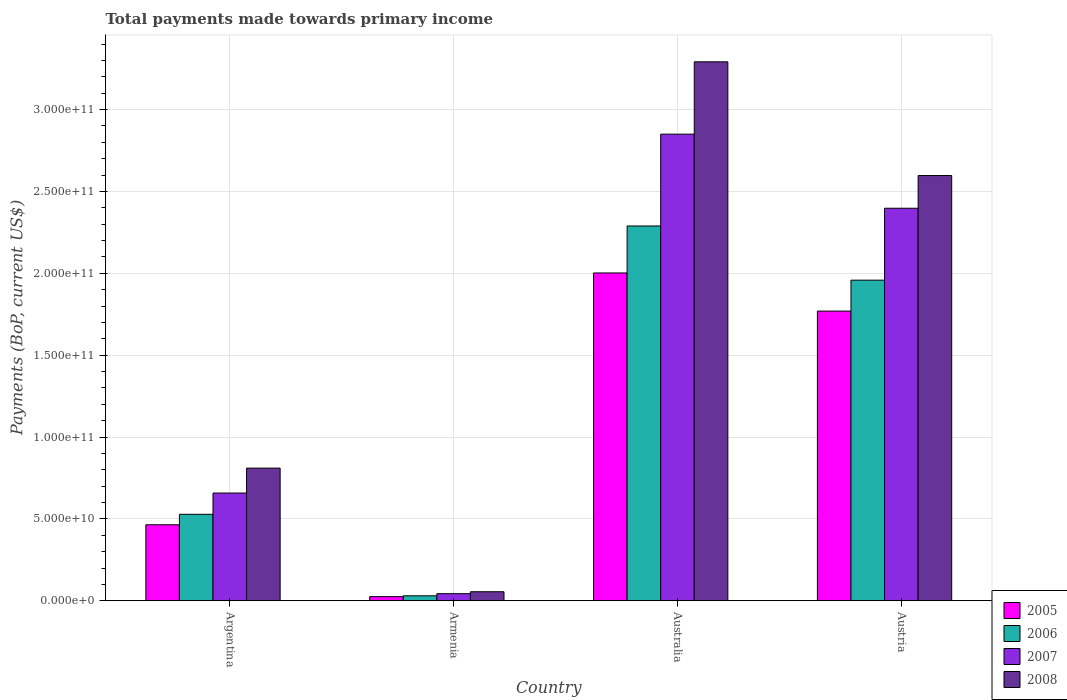How many groups of bars are there?
Provide a succinct answer. 4. Are the number of bars on each tick of the X-axis equal?
Your response must be concise. Yes. How many bars are there on the 3rd tick from the left?
Keep it short and to the point. 4. What is the label of the 2nd group of bars from the left?
Give a very brief answer. Armenia. In how many cases, is the number of bars for a given country not equal to the number of legend labels?
Your answer should be compact. 0. What is the total payments made towards primary income in 2005 in Argentina?
Give a very brief answer. 4.64e+1. Across all countries, what is the maximum total payments made towards primary income in 2006?
Provide a short and direct response. 2.29e+11. Across all countries, what is the minimum total payments made towards primary income in 2008?
Your answer should be very brief. 5.51e+09. In which country was the total payments made towards primary income in 2006 maximum?
Ensure brevity in your answer.  Australia. In which country was the total payments made towards primary income in 2005 minimum?
Give a very brief answer. Armenia. What is the total total payments made towards primary income in 2007 in the graph?
Your response must be concise. 5.95e+11. What is the difference between the total payments made towards primary income in 2006 in Argentina and that in Austria?
Offer a very short reply. -1.43e+11. What is the difference between the total payments made towards primary income in 2007 in Australia and the total payments made towards primary income in 2006 in Austria?
Offer a very short reply. 8.92e+1. What is the average total payments made towards primary income in 2008 per country?
Your answer should be compact. 1.69e+11. What is the difference between the total payments made towards primary income of/in 2006 and total payments made towards primary income of/in 2007 in Austria?
Offer a very short reply. -4.39e+1. In how many countries, is the total payments made towards primary income in 2005 greater than 20000000000 US$?
Provide a short and direct response. 3. What is the ratio of the total payments made towards primary income in 2006 in Armenia to that in Australia?
Make the answer very short. 0.01. Is the difference between the total payments made towards primary income in 2006 in Argentina and Austria greater than the difference between the total payments made towards primary income in 2007 in Argentina and Austria?
Keep it short and to the point. Yes. What is the difference between the highest and the second highest total payments made towards primary income in 2005?
Provide a short and direct response. -1.54e+11. What is the difference between the highest and the lowest total payments made towards primary income in 2007?
Ensure brevity in your answer.  2.81e+11. Is the sum of the total payments made towards primary income in 2006 in Argentina and Australia greater than the maximum total payments made towards primary income in 2008 across all countries?
Provide a short and direct response. No. Is it the case that in every country, the sum of the total payments made towards primary income in 2007 and total payments made towards primary income in 2006 is greater than the total payments made towards primary income in 2008?
Offer a terse response. Yes. How many countries are there in the graph?
Provide a short and direct response. 4. Are the values on the major ticks of Y-axis written in scientific E-notation?
Your answer should be very brief. Yes. Does the graph contain any zero values?
Offer a very short reply. No. Where does the legend appear in the graph?
Make the answer very short. Bottom right. What is the title of the graph?
Provide a succinct answer. Total payments made towards primary income. Does "1987" appear as one of the legend labels in the graph?
Provide a short and direct response. No. What is the label or title of the X-axis?
Provide a succinct answer. Country. What is the label or title of the Y-axis?
Your response must be concise. Payments (BoP, current US$). What is the Payments (BoP, current US$) in 2005 in Argentina?
Your answer should be compact. 4.64e+1. What is the Payments (BoP, current US$) in 2006 in Argentina?
Offer a terse response. 5.28e+1. What is the Payments (BoP, current US$) in 2007 in Argentina?
Make the answer very short. 6.58e+1. What is the Payments (BoP, current US$) of 2008 in Argentina?
Offer a very short reply. 8.10e+1. What is the Payments (BoP, current US$) of 2005 in Armenia?
Your answer should be compact. 2.52e+09. What is the Payments (BoP, current US$) in 2006 in Armenia?
Ensure brevity in your answer.  3.04e+09. What is the Payments (BoP, current US$) in 2007 in Armenia?
Keep it short and to the point. 4.33e+09. What is the Payments (BoP, current US$) of 2008 in Armenia?
Make the answer very short. 5.51e+09. What is the Payments (BoP, current US$) of 2005 in Australia?
Make the answer very short. 2.00e+11. What is the Payments (BoP, current US$) in 2006 in Australia?
Offer a terse response. 2.29e+11. What is the Payments (BoP, current US$) in 2007 in Australia?
Your response must be concise. 2.85e+11. What is the Payments (BoP, current US$) in 2008 in Australia?
Provide a short and direct response. 3.29e+11. What is the Payments (BoP, current US$) of 2005 in Austria?
Your response must be concise. 1.77e+11. What is the Payments (BoP, current US$) in 2006 in Austria?
Offer a very short reply. 1.96e+11. What is the Payments (BoP, current US$) of 2007 in Austria?
Provide a short and direct response. 2.40e+11. What is the Payments (BoP, current US$) of 2008 in Austria?
Your answer should be compact. 2.60e+11. Across all countries, what is the maximum Payments (BoP, current US$) of 2005?
Ensure brevity in your answer.  2.00e+11. Across all countries, what is the maximum Payments (BoP, current US$) in 2006?
Your answer should be very brief. 2.29e+11. Across all countries, what is the maximum Payments (BoP, current US$) of 2007?
Provide a succinct answer. 2.85e+11. Across all countries, what is the maximum Payments (BoP, current US$) of 2008?
Your response must be concise. 3.29e+11. Across all countries, what is the minimum Payments (BoP, current US$) of 2005?
Keep it short and to the point. 2.52e+09. Across all countries, what is the minimum Payments (BoP, current US$) in 2006?
Offer a very short reply. 3.04e+09. Across all countries, what is the minimum Payments (BoP, current US$) in 2007?
Ensure brevity in your answer.  4.33e+09. Across all countries, what is the minimum Payments (BoP, current US$) in 2008?
Your response must be concise. 5.51e+09. What is the total Payments (BoP, current US$) of 2005 in the graph?
Your answer should be compact. 4.26e+11. What is the total Payments (BoP, current US$) of 2006 in the graph?
Make the answer very short. 4.81e+11. What is the total Payments (BoP, current US$) of 2007 in the graph?
Offer a terse response. 5.95e+11. What is the total Payments (BoP, current US$) of 2008 in the graph?
Make the answer very short. 6.75e+11. What is the difference between the Payments (BoP, current US$) in 2005 in Argentina and that in Armenia?
Ensure brevity in your answer.  4.39e+1. What is the difference between the Payments (BoP, current US$) in 2006 in Argentina and that in Armenia?
Offer a very short reply. 4.98e+1. What is the difference between the Payments (BoP, current US$) of 2007 in Argentina and that in Armenia?
Offer a very short reply. 6.15e+1. What is the difference between the Payments (BoP, current US$) of 2008 in Argentina and that in Armenia?
Provide a succinct answer. 7.55e+1. What is the difference between the Payments (BoP, current US$) in 2005 in Argentina and that in Australia?
Your answer should be compact. -1.54e+11. What is the difference between the Payments (BoP, current US$) in 2006 in Argentina and that in Australia?
Your response must be concise. -1.76e+11. What is the difference between the Payments (BoP, current US$) of 2007 in Argentina and that in Australia?
Provide a short and direct response. -2.19e+11. What is the difference between the Payments (BoP, current US$) in 2008 in Argentina and that in Australia?
Give a very brief answer. -2.48e+11. What is the difference between the Payments (BoP, current US$) of 2005 in Argentina and that in Austria?
Ensure brevity in your answer.  -1.30e+11. What is the difference between the Payments (BoP, current US$) of 2006 in Argentina and that in Austria?
Provide a succinct answer. -1.43e+11. What is the difference between the Payments (BoP, current US$) of 2007 in Argentina and that in Austria?
Provide a short and direct response. -1.74e+11. What is the difference between the Payments (BoP, current US$) of 2008 in Argentina and that in Austria?
Provide a succinct answer. -1.79e+11. What is the difference between the Payments (BoP, current US$) in 2005 in Armenia and that in Australia?
Give a very brief answer. -1.98e+11. What is the difference between the Payments (BoP, current US$) of 2006 in Armenia and that in Australia?
Offer a terse response. -2.26e+11. What is the difference between the Payments (BoP, current US$) in 2007 in Armenia and that in Australia?
Provide a succinct answer. -2.81e+11. What is the difference between the Payments (BoP, current US$) in 2008 in Armenia and that in Australia?
Offer a very short reply. -3.24e+11. What is the difference between the Payments (BoP, current US$) of 2005 in Armenia and that in Austria?
Make the answer very short. -1.74e+11. What is the difference between the Payments (BoP, current US$) of 2006 in Armenia and that in Austria?
Offer a very short reply. -1.93e+11. What is the difference between the Payments (BoP, current US$) of 2007 in Armenia and that in Austria?
Make the answer very short. -2.35e+11. What is the difference between the Payments (BoP, current US$) in 2008 in Armenia and that in Austria?
Offer a very short reply. -2.54e+11. What is the difference between the Payments (BoP, current US$) of 2005 in Australia and that in Austria?
Offer a very short reply. 2.33e+1. What is the difference between the Payments (BoP, current US$) of 2006 in Australia and that in Austria?
Your answer should be compact. 3.31e+1. What is the difference between the Payments (BoP, current US$) of 2007 in Australia and that in Austria?
Your answer should be very brief. 4.52e+1. What is the difference between the Payments (BoP, current US$) in 2008 in Australia and that in Austria?
Make the answer very short. 6.94e+1. What is the difference between the Payments (BoP, current US$) of 2005 in Argentina and the Payments (BoP, current US$) of 2006 in Armenia?
Your answer should be compact. 4.34e+1. What is the difference between the Payments (BoP, current US$) in 2005 in Argentina and the Payments (BoP, current US$) in 2007 in Armenia?
Keep it short and to the point. 4.21e+1. What is the difference between the Payments (BoP, current US$) in 2005 in Argentina and the Payments (BoP, current US$) in 2008 in Armenia?
Make the answer very short. 4.09e+1. What is the difference between the Payments (BoP, current US$) of 2006 in Argentina and the Payments (BoP, current US$) of 2007 in Armenia?
Your answer should be compact. 4.85e+1. What is the difference between the Payments (BoP, current US$) of 2006 in Argentina and the Payments (BoP, current US$) of 2008 in Armenia?
Make the answer very short. 4.73e+1. What is the difference between the Payments (BoP, current US$) of 2007 in Argentina and the Payments (BoP, current US$) of 2008 in Armenia?
Offer a very short reply. 6.03e+1. What is the difference between the Payments (BoP, current US$) of 2005 in Argentina and the Payments (BoP, current US$) of 2006 in Australia?
Make the answer very short. -1.82e+11. What is the difference between the Payments (BoP, current US$) in 2005 in Argentina and the Payments (BoP, current US$) in 2007 in Australia?
Your answer should be compact. -2.39e+11. What is the difference between the Payments (BoP, current US$) in 2005 in Argentina and the Payments (BoP, current US$) in 2008 in Australia?
Make the answer very short. -2.83e+11. What is the difference between the Payments (BoP, current US$) in 2006 in Argentina and the Payments (BoP, current US$) in 2007 in Australia?
Your answer should be very brief. -2.32e+11. What is the difference between the Payments (BoP, current US$) in 2006 in Argentina and the Payments (BoP, current US$) in 2008 in Australia?
Make the answer very short. -2.76e+11. What is the difference between the Payments (BoP, current US$) in 2007 in Argentina and the Payments (BoP, current US$) in 2008 in Australia?
Provide a succinct answer. -2.63e+11. What is the difference between the Payments (BoP, current US$) of 2005 in Argentina and the Payments (BoP, current US$) of 2006 in Austria?
Ensure brevity in your answer.  -1.49e+11. What is the difference between the Payments (BoP, current US$) of 2005 in Argentina and the Payments (BoP, current US$) of 2007 in Austria?
Make the answer very short. -1.93e+11. What is the difference between the Payments (BoP, current US$) in 2005 in Argentina and the Payments (BoP, current US$) in 2008 in Austria?
Your answer should be compact. -2.13e+11. What is the difference between the Payments (BoP, current US$) of 2006 in Argentina and the Payments (BoP, current US$) of 2007 in Austria?
Provide a short and direct response. -1.87e+11. What is the difference between the Payments (BoP, current US$) in 2006 in Argentina and the Payments (BoP, current US$) in 2008 in Austria?
Your response must be concise. -2.07e+11. What is the difference between the Payments (BoP, current US$) of 2007 in Argentina and the Payments (BoP, current US$) of 2008 in Austria?
Give a very brief answer. -1.94e+11. What is the difference between the Payments (BoP, current US$) of 2005 in Armenia and the Payments (BoP, current US$) of 2006 in Australia?
Give a very brief answer. -2.26e+11. What is the difference between the Payments (BoP, current US$) of 2005 in Armenia and the Payments (BoP, current US$) of 2007 in Australia?
Provide a succinct answer. -2.82e+11. What is the difference between the Payments (BoP, current US$) in 2005 in Armenia and the Payments (BoP, current US$) in 2008 in Australia?
Your response must be concise. -3.27e+11. What is the difference between the Payments (BoP, current US$) in 2006 in Armenia and the Payments (BoP, current US$) in 2007 in Australia?
Provide a short and direct response. -2.82e+11. What is the difference between the Payments (BoP, current US$) of 2006 in Armenia and the Payments (BoP, current US$) of 2008 in Australia?
Offer a terse response. -3.26e+11. What is the difference between the Payments (BoP, current US$) in 2007 in Armenia and the Payments (BoP, current US$) in 2008 in Australia?
Your answer should be compact. -3.25e+11. What is the difference between the Payments (BoP, current US$) in 2005 in Armenia and the Payments (BoP, current US$) in 2006 in Austria?
Your response must be concise. -1.93e+11. What is the difference between the Payments (BoP, current US$) in 2005 in Armenia and the Payments (BoP, current US$) in 2007 in Austria?
Give a very brief answer. -2.37e+11. What is the difference between the Payments (BoP, current US$) in 2005 in Armenia and the Payments (BoP, current US$) in 2008 in Austria?
Your answer should be compact. -2.57e+11. What is the difference between the Payments (BoP, current US$) of 2006 in Armenia and the Payments (BoP, current US$) of 2007 in Austria?
Your answer should be compact. -2.37e+11. What is the difference between the Payments (BoP, current US$) of 2006 in Armenia and the Payments (BoP, current US$) of 2008 in Austria?
Offer a terse response. -2.57e+11. What is the difference between the Payments (BoP, current US$) of 2007 in Armenia and the Payments (BoP, current US$) of 2008 in Austria?
Provide a succinct answer. -2.55e+11. What is the difference between the Payments (BoP, current US$) in 2005 in Australia and the Payments (BoP, current US$) in 2006 in Austria?
Provide a short and direct response. 4.39e+09. What is the difference between the Payments (BoP, current US$) of 2005 in Australia and the Payments (BoP, current US$) of 2007 in Austria?
Provide a succinct answer. -3.95e+1. What is the difference between the Payments (BoP, current US$) in 2005 in Australia and the Payments (BoP, current US$) in 2008 in Austria?
Keep it short and to the point. -5.95e+1. What is the difference between the Payments (BoP, current US$) of 2006 in Australia and the Payments (BoP, current US$) of 2007 in Austria?
Keep it short and to the point. -1.08e+1. What is the difference between the Payments (BoP, current US$) of 2006 in Australia and the Payments (BoP, current US$) of 2008 in Austria?
Your answer should be very brief. -3.08e+1. What is the difference between the Payments (BoP, current US$) of 2007 in Australia and the Payments (BoP, current US$) of 2008 in Austria?
Your response must be concise. 2.53e+1. What is the average Payments (BoP, current US$) in 2005 per country?
Keep it short and to the point. 1.07e+11. What is the average Payments (BoP, current US$) of 2006 per country?
Ensure brevity in your answer.  1.20e+11. What is the average Payments (BoP, current US$) in 2007 per country?
Provide a short and direct response. 1.49e+11. What is the average Payments (BoP, current US$) of 2008 per country?
Offer a terse response. 1.69e+11. What is the difference between the Payments (BoP, current US$) in 2005 and Payments (BoP, current US$) in 2006 in Argentina?
Your response must be concise. -6.39e+09. What is the difference between the Payments (BoP, current US$) in 2005 and Payments (BoP, current US$) in 2007 in Argentina?
Provide a short and direct response. -1.94e+1. What is the difference between the Payments (BoP, current US$) of 2005 and Payments (BoP, current US$) of 2008 in Argentina?
Offer a very short reply. -3.46e+1. What is the difference between the Payments (BoP, current US$) of 2006 and Payments (BoP, current US$) of 2007 in Argentina?
Give a very brief answer. -1.30e+1. What is the difference between the Payments (BoP, current US$) of 2006 and Payments (BoP, current US$) of 2008 in Argentina?
Offer a terse response. -2.82e+1. What is the difference between the Payments (BoP, current US$) in 2007 and Payments (BoP, current US$) in 2008 in Argentina?
Give a very brief answer. -1.52e+1. What is the difference between the Payments (BoP, current US$) of 2005 and Payments (BoP, current US$) of 2006 in Armenia?
Offer a terse response. -5.16e+08. What is the difference between the Payments (BoP, current US$) in 2005 and Payments (BoP, current US$) in 2007 in Armenia?
Offer a very short reply. -1.81e+09. What is the difference between the Payments (BoP, current US$) of 2005 and Payments (BoP, current US$) of 2008 in Armenia?
Provide a short and direct response. -2.99e+09. What is the difference between the Payments (BoP, current US$) of 2006 and Payments (BoP, current US$) of 2007 in Armenia?
Your answer should be very brief. -1.30e+09. What is the difference between the Payments (BoP, current US$) of 2006 and Payments (BoP, current US$) of 2008 in Armenia?
Keep it short and to the point. -2.48e+09. What is the difference between the Payments (BoP, current US$) in 2007 and Payments (BoP, current US$) in 2008 in Armenia?
Provide a succinct answer. -1.18e+09. What is the difference between the Payments (BoP, current US$) of 2005 and Payments (BoP, current US$) of 2006 in Australia?
Your response must be concise. -2.87e+1. What is the difference between the Payments (BoP, current US$) in 2005 and Payments (BoP, current US$) in 2007 in Australia?
Offer a very short reply. -8.48e+1. What is the difference between the Payments (BoP, current US$) of 2005 and Payments (BoP, current US$) of 2008 in Australia?
Offer a terse response. -1.29e+11. What is the difference between the Payments (BoP, current US$) of 2006 and Payments (BoP, current US$) of 2007 in Australia?
Give a very brief answer. -5.61e+1. What is the difference between the Payments (BoP, current US$) in 2006 and Payments (BoP, current US$) in 2008 in Australia?
Ensure brevity in your answer.  -1.00e+11. What is the difference between the Payments (BoP, current US$) in 2007 and Payments (BoP, current US$) in 2008 in Australia?
Provide a short and direct response. -4.42e+1. What is the difference between the Payments (BoP, current US$) of 2005 and Payments (BoP, current US$) of 2006 in Austria?
Offer a terse response. -1.89e+1. What is the difference between the Payments (BoP, current US$) in 2005 and Payments (BoP, current US$) in 2007 in Austria?
Provide a succinct answer. -6.28e+1. What is the difference between the Payments (BoP, current US$) of 2005 and Payments (BoP, current US$) of 2008 in Austria?
Your response must be concise. -8.28e+1. What is the difference between the Payments (BoP, current US$) of 2006 and Payments (BoP, current US$) of 2007 in Austria?
Provide a short and direct response. -4.39e+1. What is the difference between the Payments (BoP, current US$) of 2006 and Payments (BoP, current US$) of 2008 in Austria?
Offer a very short reply. -6.39e+1. What is the difference between the Payments (BoP, current US$) of 2007 and Payments (BoP, current US$) of 2008 in Austria?
Ensure brevity in your answer.  -2.00e+1. What is the ratio of the Payments (BoP, current US$) of 2005 in Argentina to that in Armenia?
Provide a short and direct response. 18.42. What is the ratio of the Payments (BoP, current US$) of 2006 in Argentina to that in Armenia?
Your response must be concise. 17.39. What is the ratio of the Payments (BoP, current US$) of 2007 in Argentina to that in Armenia?
Keep it short and to the point. 15.18. What is the ratio of the Payments (BoP, current US$) of 2008 in Argentina to that in Armenia?
Make the answer very short. 14.7. What is the ratio of the Payments (BoP, current US$) in 2005 in Argentina to that in Australia?
Give a very brief answer. 0.23. What is the ratio of the Payments (BoP, current US$) of 2006 in Argentina to that in Australia?
Offer a terse response. 0.23. What is the ratio of the Payments (BoP, current US$) of 2007 in Argentina to that in Australia?
Make the answer very short. 0.23. What is the ratio of the Payments (BoP, current US$) of 2008 in Argentina to that in Australia?
Your response must be concise. 0.25. What is the ratio of the Payments (BoP, current US$) of 2005 in Argentina to that in Austria?
Make the answer very short. 0.26. What is the ratio of the Payments (BoP, current US$) in 2006 in Argentina to that in Austria?
Make the answer very short. 0.27. What is the ratio of the Payments (BoP, current US$) of 2007 in Argentina to that in Austria?
Make the answer very short. 0.27. What is the ratio of the Payments (BoP, current US$) of 2008 in Argentina to that in Austria?
Keep it short and to the point. 0.31. What is the ratio of the Payments (BoP, current US$) of 2005 in Armenia to that in Australia?
Give a very brief answer. 0.01. What is the ratio of the Payments (BoP, current US$) in 2006 in Armenia to that in Australia?
Provide a succinct answer. 0.01. What is the ratio of the Payments (BoP, current US$) of 2007 in Armenia to that in Australia?
Make the answer very short. 0.02. What is the ratio of the Payments (BoP, current US$) in 2008 in Armenia to that in Australia?
Your answer should be compact. 0.02. What is the ratio of the Payments (BoP, current US$) of 2005 in Armenia to that in Austria?
Offer a very short reply. 0.01. What is the ratio of the Payments (BoP, current US$) in 2006 in Armenia to that in Austria?
Ensure brevity in your answer.  0.02. What is the ratio of the Payments (BoP, current US$) of 2007 in Armenia to that in Austria?
Offer a very short reply. 0.02. What is the ratio of the Payments (BoP, current US$) of 2008 in Armenia to that in Austria?
Give a very brief answer. 0.02. What is the ratio of the Payments (BoP, current US$) of 2005 in Australia to that in Austria?
Offer a terse response. 1.13. What is the ratio of the Payments (BoP, current US$) in 2006 in Australia to that in Austria?
Provide a succinct answer. 1.17. What is the ratio of the Payments (BoP, current US$) of 2007 in Australia to that in Austria?
Your answer should be very brief. 1.19. What is the ratio of the Payments (BoP, current US$) in 2008 in Australia to that in Austria?
Your answer should be compact. 1.27. What is the difference between the highest and the second highest Payments (BoP, current US$) of 2005?
Your response must be concise. 2.33e+1. What is the difference between the highest and the second highest Payments (BoP, current US$) of 2006?
Your answer should be very brief. 3.31e+1. What is the difference between the highest and the second highest Payments (BoP, current US$) of 2007?
Provide a short and direct response. 4.52e+1. What is the difference between the highest and the second highest Payments (BoP, current US$) in 2008?
Keep it short and to the point. 6.94e+1. What is the difference between the highest and the lowest Payments (BoP, current US$) in 2005?
Provide a succinct answer. 1.98e+11. What is the difference between the highest and the lowest Payments (BoP, current US$) of 2006?
Keep it short and to the point. 2.26e+11. What is the difference between the highest and the lowest Payments (BoP, current US$) in 2007?
Your response must be concise. 2.81e+11. What is the difference between the highest and the lowest Payments (BoP, current US$) in 2008?
Offer a very short reply. 3.24e+11. 